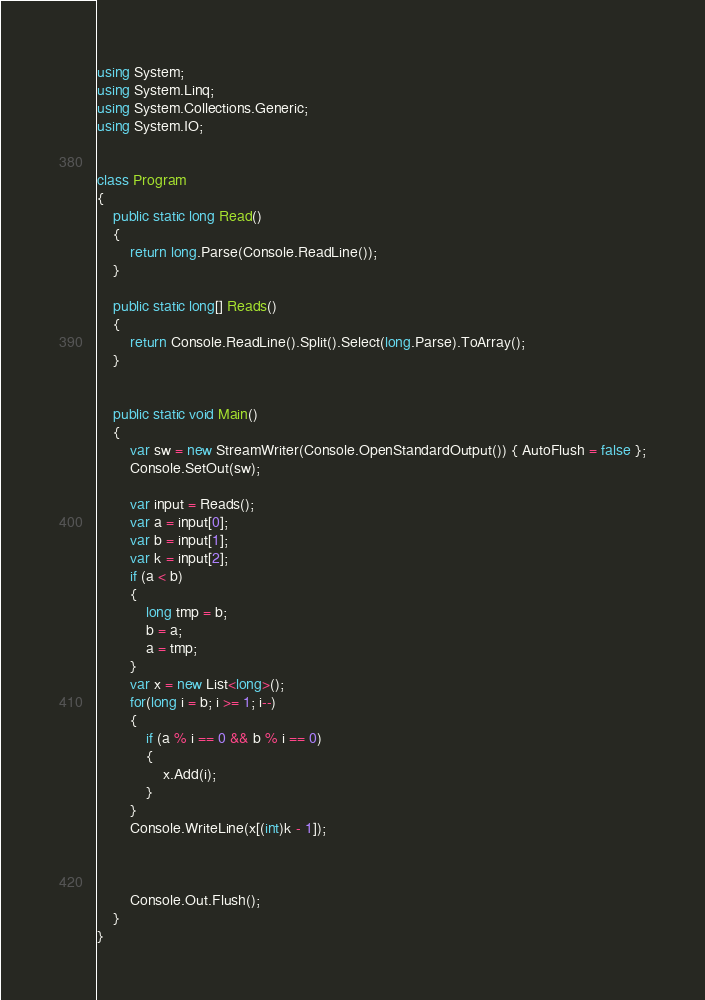<code> <loc_0><loc_0><loc_500><loc_500><_C#_>using System;
using System.Linq;
using System.Collections.Generic;
using System.IO;


class Program
{
    public static long Read()
    {
        return long.Parse(Console.ReadLine());
    }

    public static long[] Reads()
    {
        return Console.ReadLine().Split().Select(long.Parse).ToArray();
    }


    public static void Main()
    {
        var sw = new StreamWriter(Console.OpenStandardOutput()) { AutoFlush = false };
        Console.SetOut(sw);

        var input = Reads();
        var a = input[0];
        var b = input[1];
        var k = input[2];
        if (a < b)
        {
            long tmp = b;
            b = a;
            a = tmp;
        }
        var x = new List<long>();
        for(long i = b; i >= 1; i--)
        {
            if (a % i == 0 && b % i == 0)
            {
                x.Add(i);
            }
        }
        Console.WriteLine(x[(int)k - 1]);



        Console.Out.Flush();
    }
}</code> 